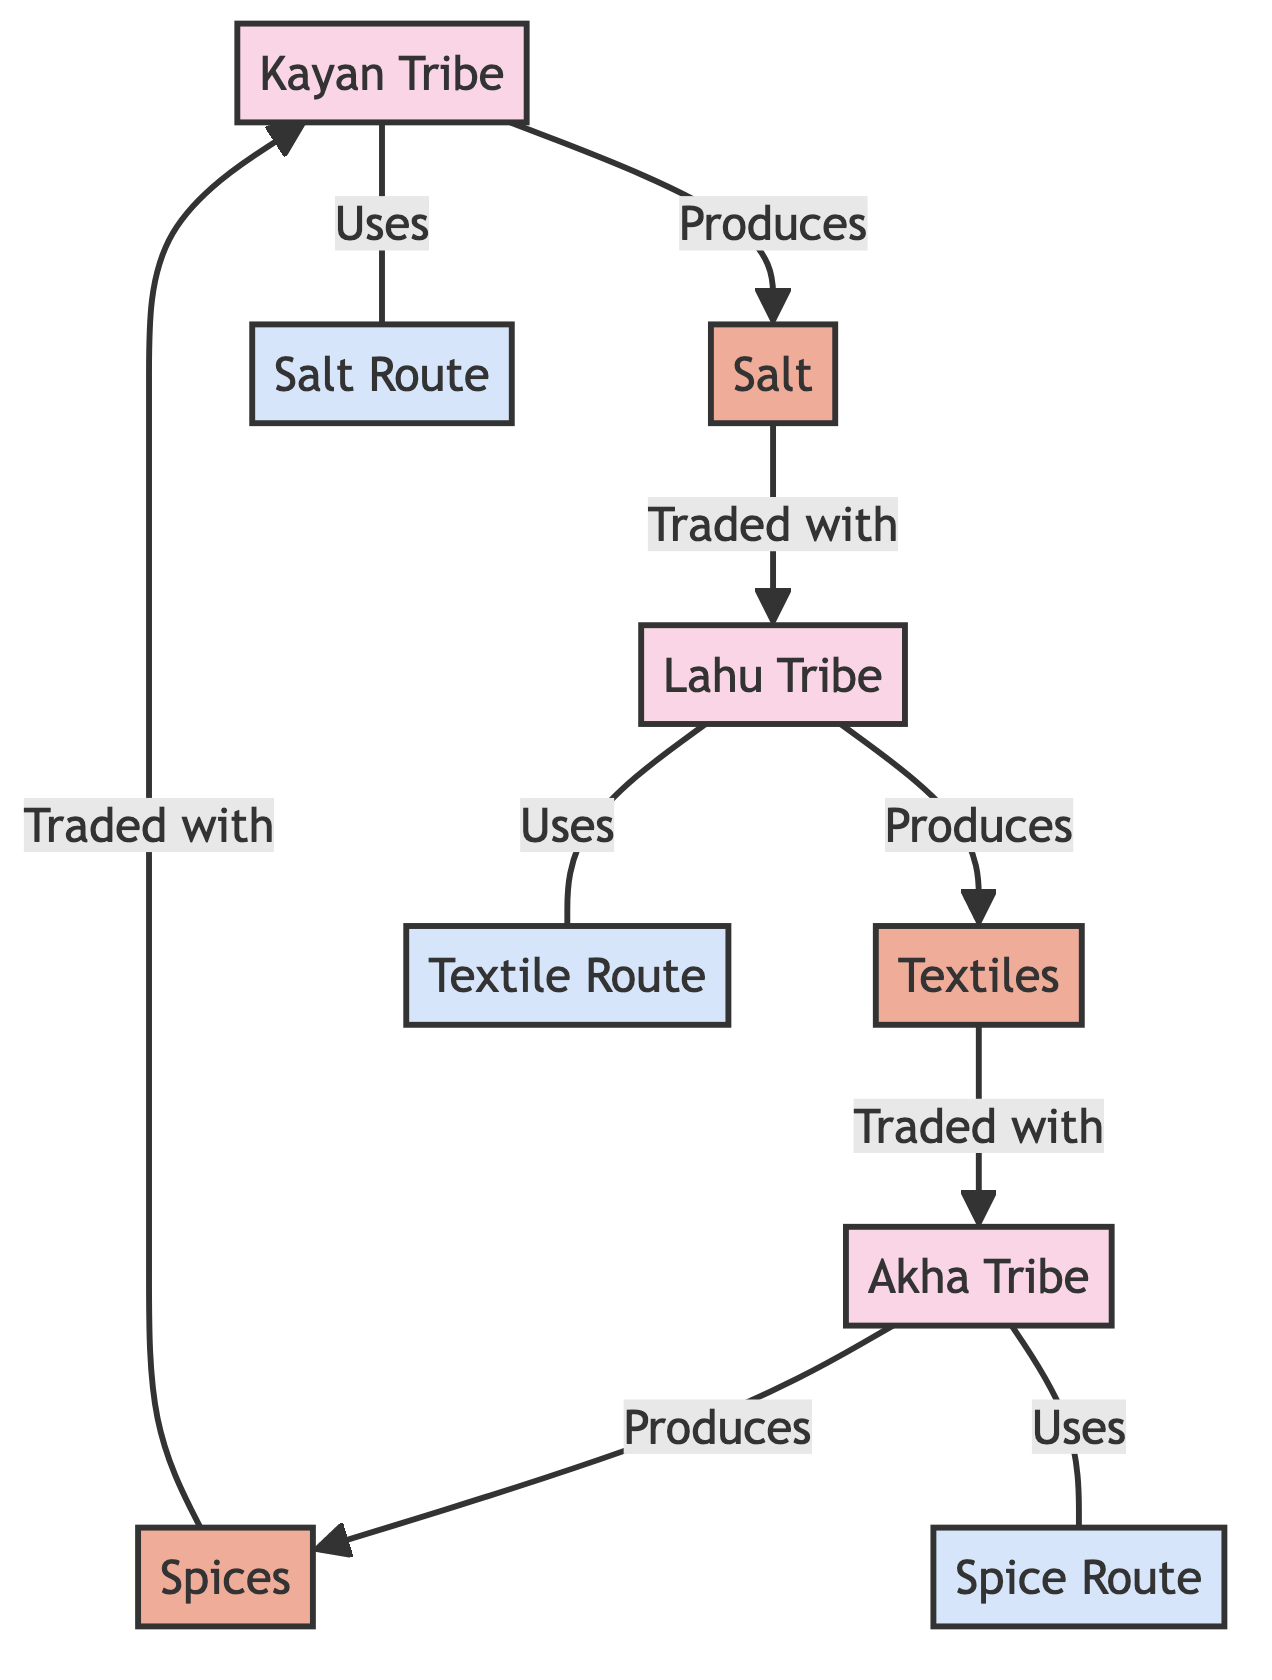What is the total number of tribes in the diagram? The diagram lists three distinct tribes: Kayan, Lahu, and Akha. Each tribe is represented as a separate node. By counting these nodes, we find there are three tribes.
Answer: 3 Which tribe produces textiles? The diagram directly links the Lahu tribe to the textiles node with the label "Produces." This indicates that Lahu is responsible for producing textiles.
Answer: Lahu Tribe What type of goods does the Kayan tribe trade with? The arrow leading from the spices node to the Kayan tribe labeled "Traded with" shows that the Kayan tribe engages in trading spices.
Answer: Spices How many trade routes are depicted in the diagram? There are three designated trade routes listed: Salt Route, Textile Route, and Spice Route. Each route is represented with a unique node, leading to a total count of three trade routes.
Answer: 3 Which goods are traded between the Lahu tribe and neighboring tribes? The diagram shows that the Lahu tribe trades textiles. The link from the textiles node to the Akha tribe labeled "Traded with" confirms this exchange between these tribes.
Answer: Textiles Which tribe uses the salt route? The diagram indicates that the Kayan tribe uses the Salt Route. This is shown through the connection labeled "Uses" from the Kayan tribe to the Salt Route node.
Answer: Kayan Tribe What is the relationship between the Akha tribe and spices? The diagram illustrates a trade relationship where spices are traded with the Kayan tribe, linking the Akha tribe indirectly through the goods exchange. Thus, the Akha tribe does not directly trade spices, but they are involved in a network that includes spices through the trade.
Answer: Traded with Kayan Tribe What do the Lahu and Akha tribes have in common regarding their products? Both the Lahu and Akha tribes produce distinct goods, textiles, and spices respectively, indicating unique contributions to their trade networks, with no overlap in product types. However, they are involved in different paths of trade noted in the diagram.
Answer: Distinct products How does the Kayan tribe connect to the trade of salt? The diagram outlines a clear connection where the Kayan tribe is linked to the salt node with the label "Produces." This indicates their involvement in the salt trade, having a trade route specifically for that interaction.
Answer: Salt Route 